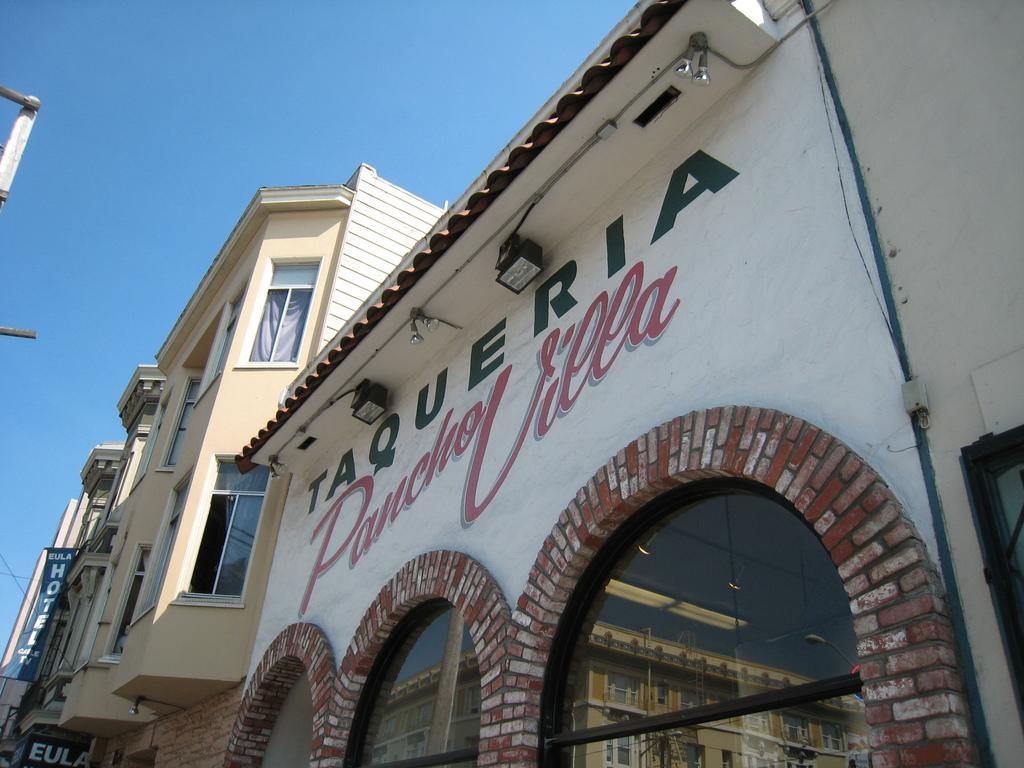What type of structures are present in the image? There are buildings in the image. What feature can be observed on the buildings? The buildings have glass windows. How can the buildings be identified in the image? The buildings have name plates. What is the condition of the sky in the image? The sky is clear in the image. Can you see any ants crawling on the buildings in the image? There are no ants present in the image; it features buildings with glass windows and name plates. What type of magic is being performed on the buildings in the image? There is no magic present in the image; it is a realistic depiction of buildings with glass windows and name plates. 